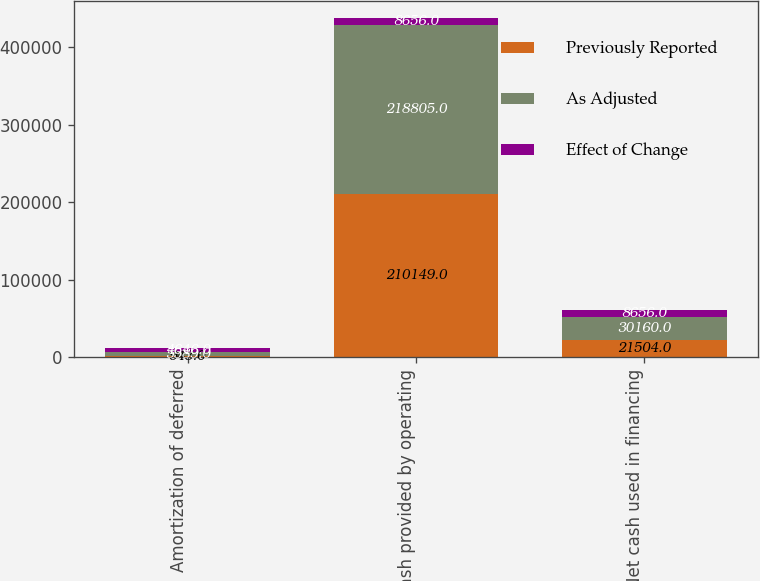Convert chart to OTSL. <chart><loc_0><loc_0><loc_500><loc_500><stacked_bar_chart><ecel><fcel>Amortization of deferred<fcel>Net cash provided by operating<fcel>Net cash used in financing<nl><fcel>Previously Reported<fcel>943<fcel>210149<fcel>21504<nl><fcel>As Adjusted<fcel>5589<fcel>218805<fcel>30160<nl><fcel>Effect of Change<fcel>4646<fcel>8656<fcel>8656<nl></chart> 